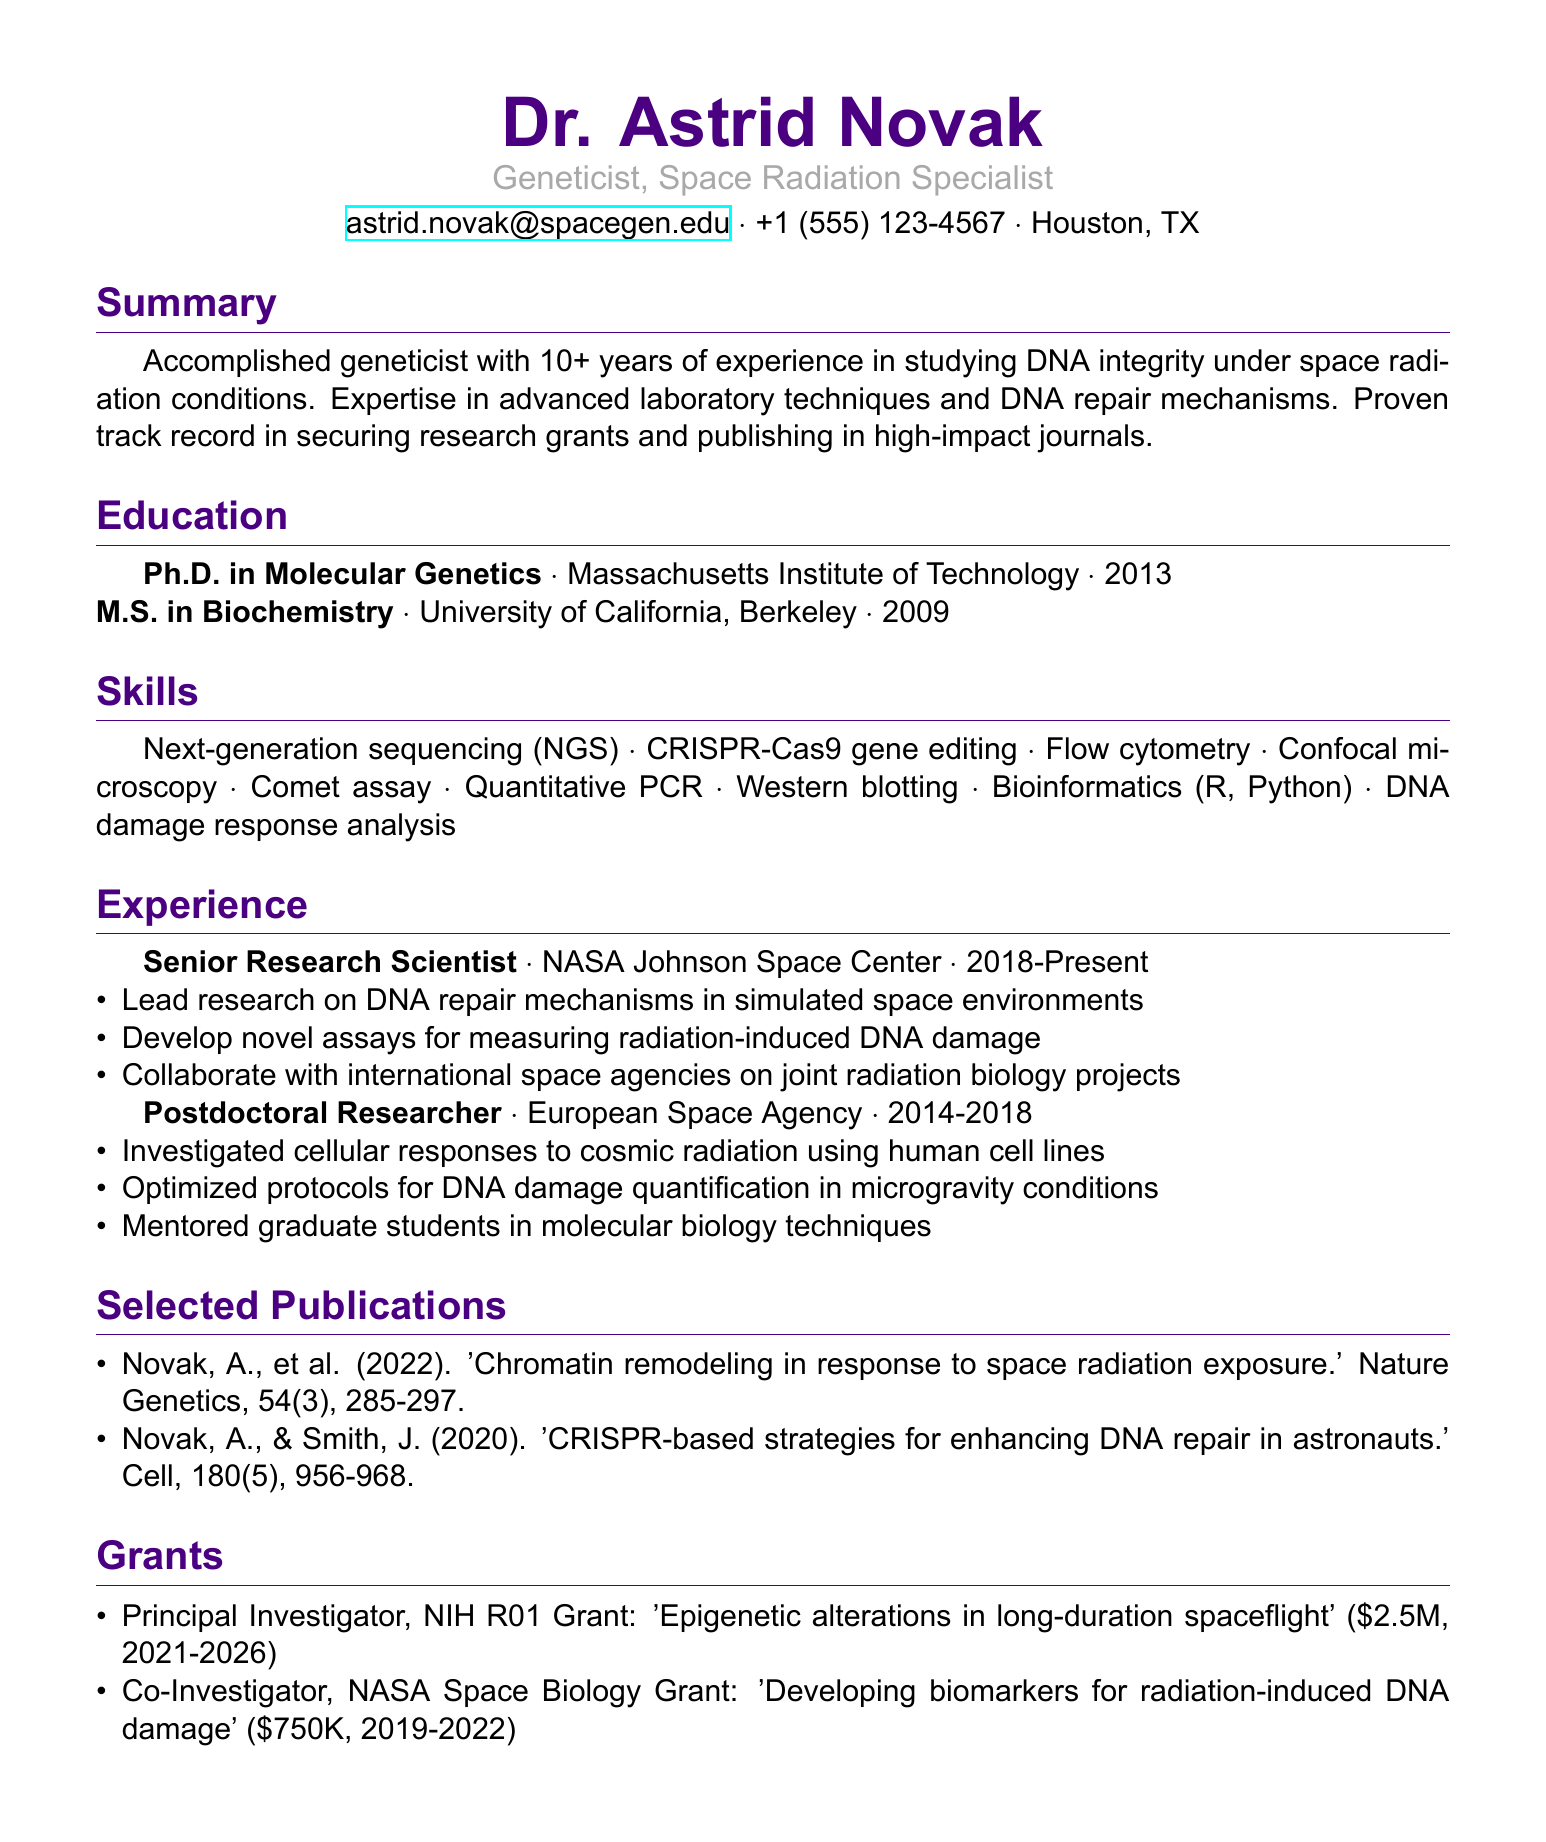what is the name of the individual? The name of the individual is presented at the top of the document under the personal information section.
Answer: Dr. Astrid Novak what is the title of Dr. Astrid Novak? The title reflects her professional specialization and area of research as listed in the document.
Answer: Geneticist, Space Radiation Specialist what year did Dr. Astrid Novak receive her Ph.D.? The year of her Ph.D. is noted in the education section of the document.
Answer: 2013 how many years of experience does Dr. Astrid Novak have? The summary section provides information on her experience in the field, quantified in years.
Answer: 10+ which laboratory technique is mentioned first in the skills section? The order of skills listed in the document indicates the sequence of laboratory techniques, with the first being highlighted.
Answer: Next-generation sequencing (NGS) in which organization does Dr. Astrid Novak currently work? The current position and organization are specified in the experience section of the document.
Answer: NASA Johnson Space Center how much funding did Dr. Astrid Novak secure for the NIH R01 Grant? The financial specifics of the grants are outlined in the grants section.
Answer: $2.5M what is the focus of the publication from 2022? The title of the publication gives insight into the subject matter of the research conducted by Dr. Novak in that year.
Answer: Chromatin remodeling in response to space radiation exposure how many publications are listed in the document? The document lists individual publications, allowing for a count of how many are included.
Answer: 2 which position did Dr. Astrid Novak hold before becoming a Senior Research Scientist? The experience section details her preceding role prior to her current position.
Answer: Postdoctoral Researcher 